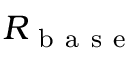Convert formula to latex. <formula><loc_0><loc_0><loc_500><loc_500>R _ { b a s e }</formula> 